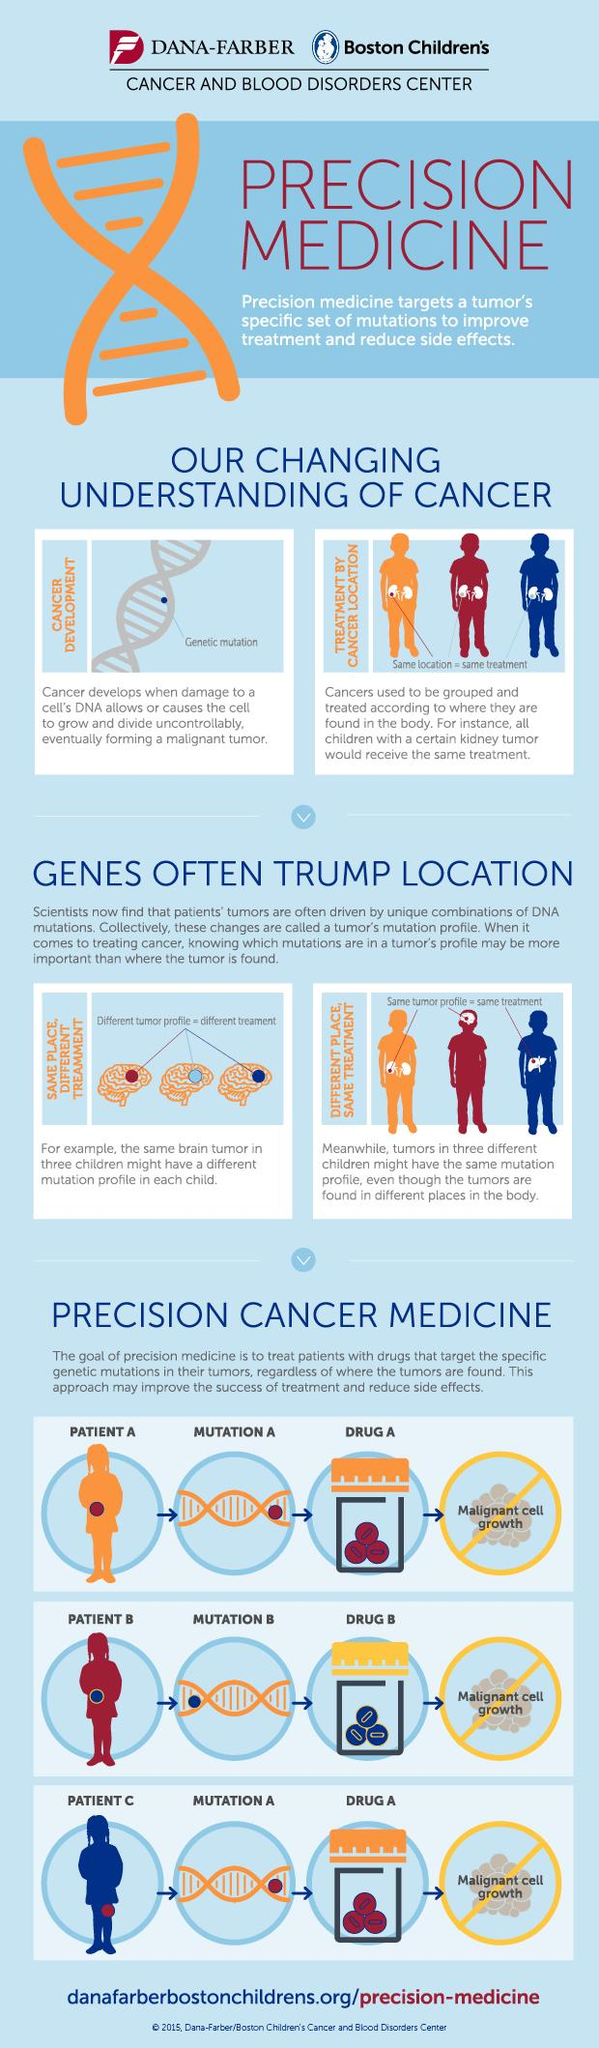Point out several critical features in this image. It has been determined that Drug A is red in color. The organ shown in the pictures related to cancer treatment by location is the kidney. The organ shown in the picture related to the same place, different treatment is the brain. 